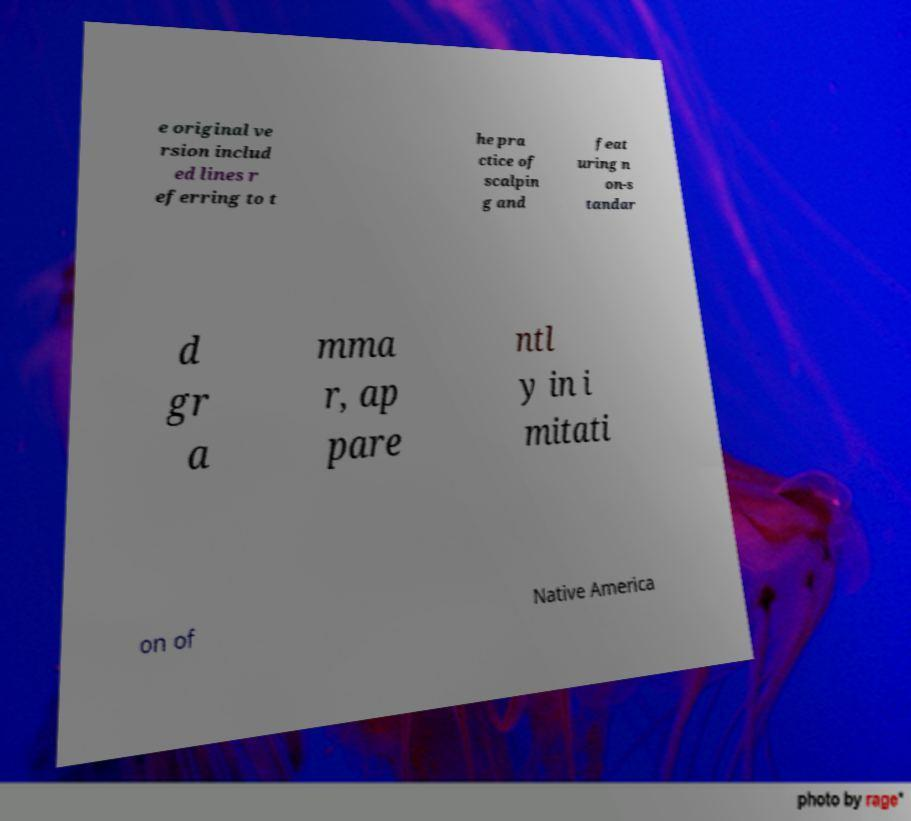I need the written content from this picture converted into text. Can you do that? e original ve rsion includ ed lines r eferring to t he pra ctice of scalpin g and feat uring n on-s tandar d gr a mma r, ap pare ntl y in i mitati on of Native America 